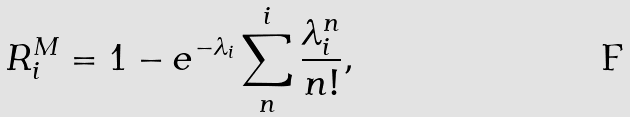<formula> <loc_0><loc_0><loc_500><loc_500>R ^ { M } _ { i } = 1 - e ^ { - \lambda _ { i } } \sum _ { n } ^ { i } \frac { \lambda _ { i } ^ { n } } { n ! } ,</formula> 